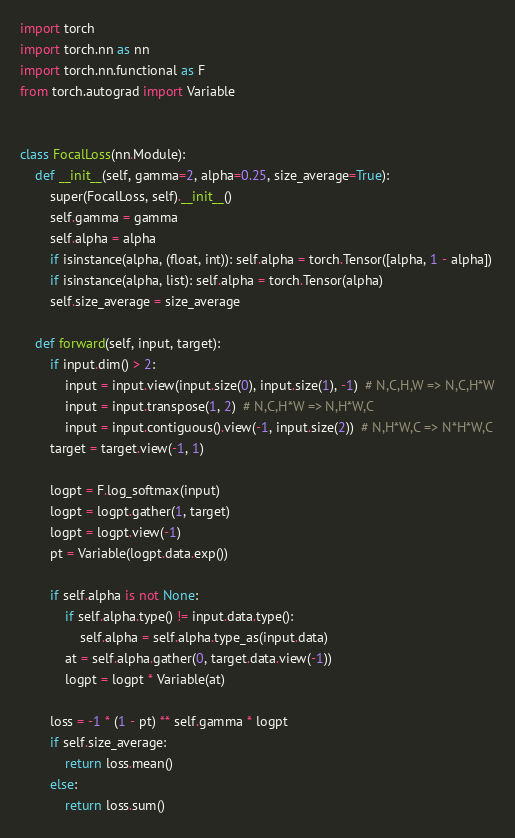Convert code to text. <code><loc_0><loc_0><loc_500><loc_500><_Python_>import torch
import torch.nn as nn
import torch.nn.functional as F
from torch.autograd import Variable


class FocalLoss(nn.Module):
    def __init__(self, gamma=2, alpha=0.25, size_average=True):
        super(FocalLoss, self).__init__()
        self.gamma = gamma
        self.alpha = alpha
        if isinstance(alpha, (float, int)): self.alpha = torch.Tensor([alpha, 1 - alpha])
        if isinstance(alpha, list): self.alpha = torch.Tensor(alpha)
        self.size_average = size_average

    def forward(self, input, target):
        if input.dim() > 2:
            input = input.view(input.size(0), input.size(1), -1)  # N,C,H,W => N,C,H*W
            input = input.transpose(1, 2)  # N,C,H*W => N,H*W,C
            input = input.contiguous().view(-1, input.size(2))  # N,H*W,C => N*H*W,C
        target = target.view(-1, 1)

        logpt = F.log_softmax(input)
        logpt = logpt.gather(1, target)
        logpt = logpt.view(-1)
        pt = Variable(logpt.data.exp())

        if self.alpha is not None:
            if self.alpha.type() != input.data.type():
                self.alpha = self.alpha.type_as(input.data)
            at = self.alpha.gather(0, target.data.view(-1))
            logpt = logpt * Variable(at)

        loss = -1 * (1 - pt) ** self.gamma * logpt
        if self.size_average:
            return loss.mean()
        else:
            return loss.sum()
</code> 